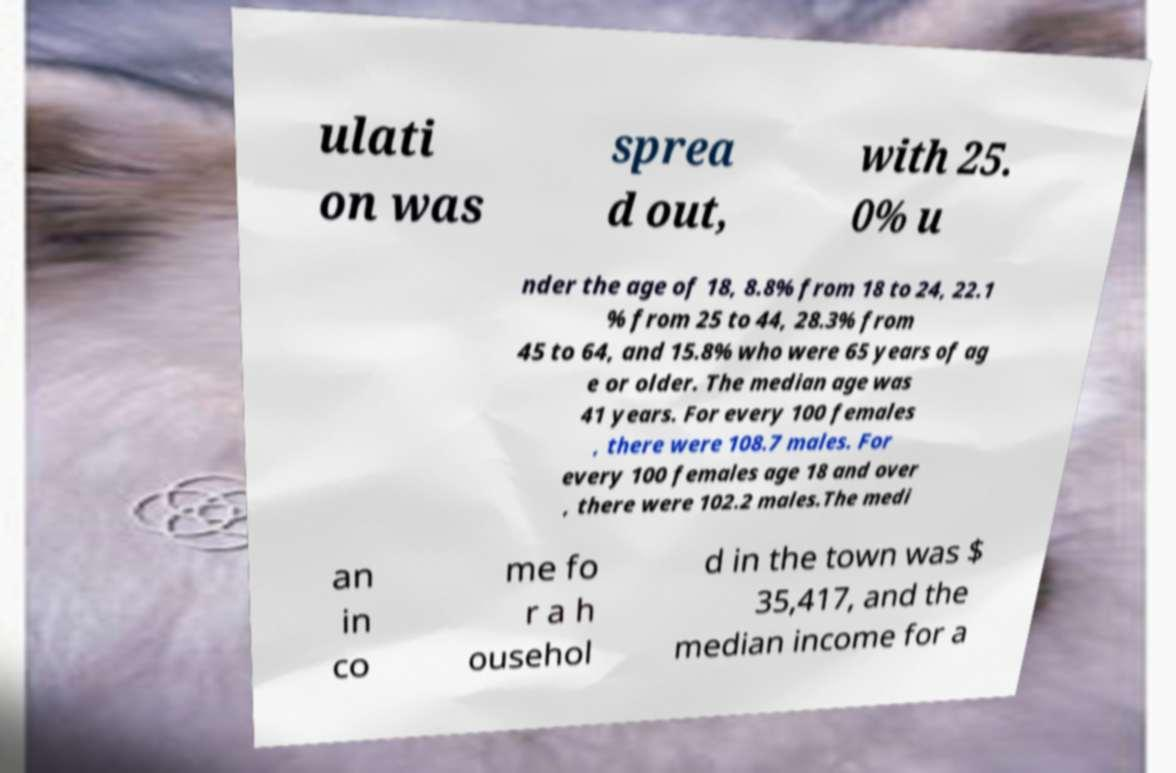For documentation purposes, I need the text within this image transcribed. Could you provide that? ulati on was sprea d out, with 25. 0% u nder the age of 18, 8.8% from 18 to 24, 22.1 % from 25 to 44, 28.3% from 45 to 64, and 15.8% who were 65 years of ag e or older. The median age was 41 years. For every 100 females , there were 108.7 males. For every 100 females age 18 and over , there were 102.2 males.The medi an in co me fo r a h ousehol d in the town was $ 35,417, and the median income for a 